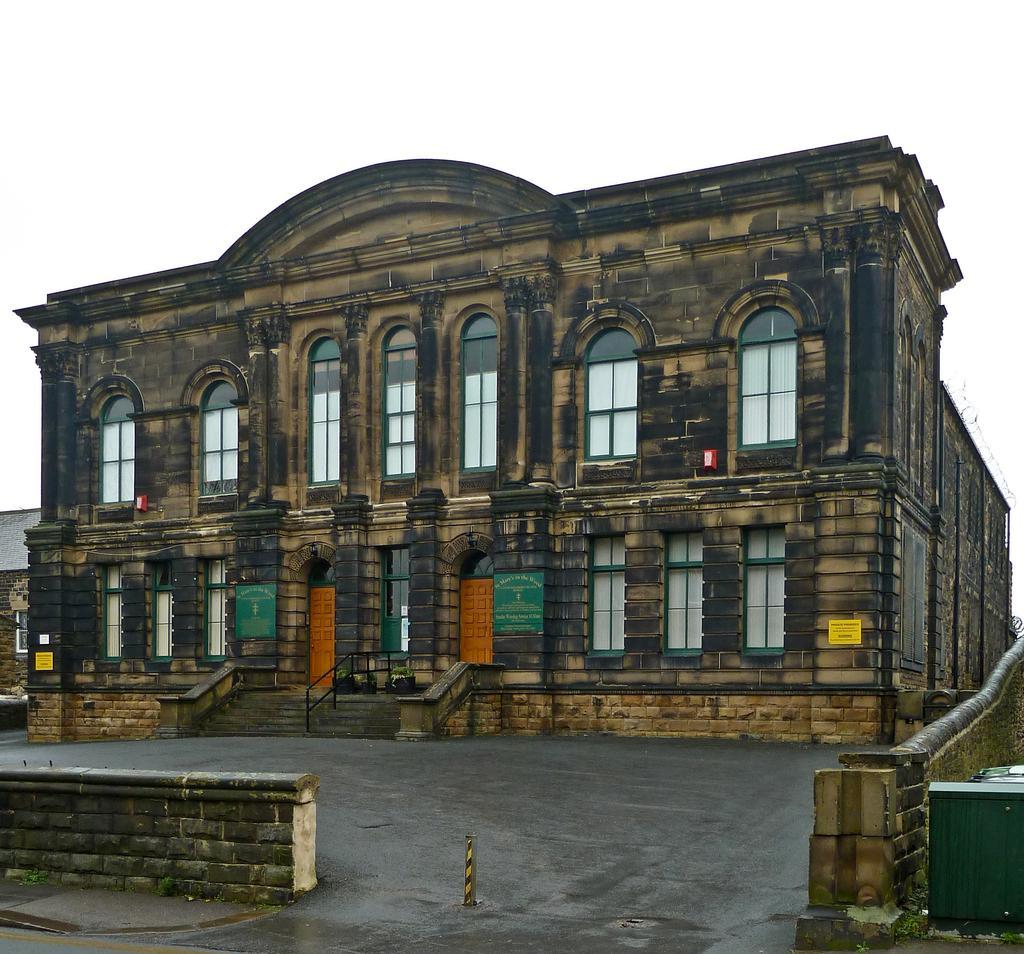Please provide a concise description of this image. In this image we can see there is a building. In the background there is a sky. 